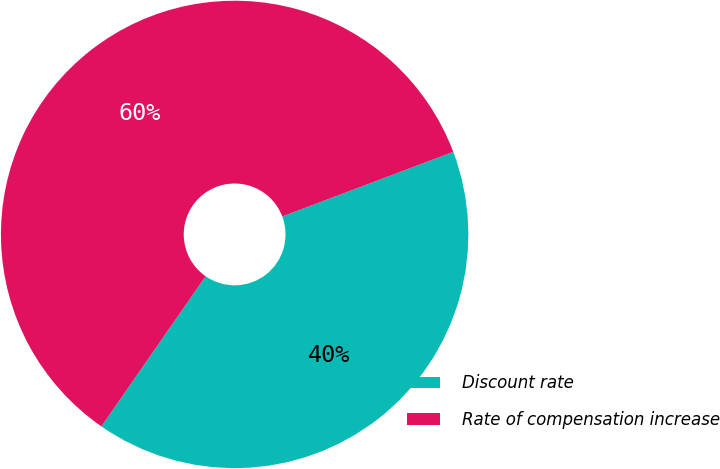Convert chart to OTSL. <chart><loc_0><loc_0><loc_500><loc_500><pie_chart><fcel>Discount rate<fcel>Rate of compensation increase<nl><fcel>40.4%<fcel>59.6%<nl></chart> 